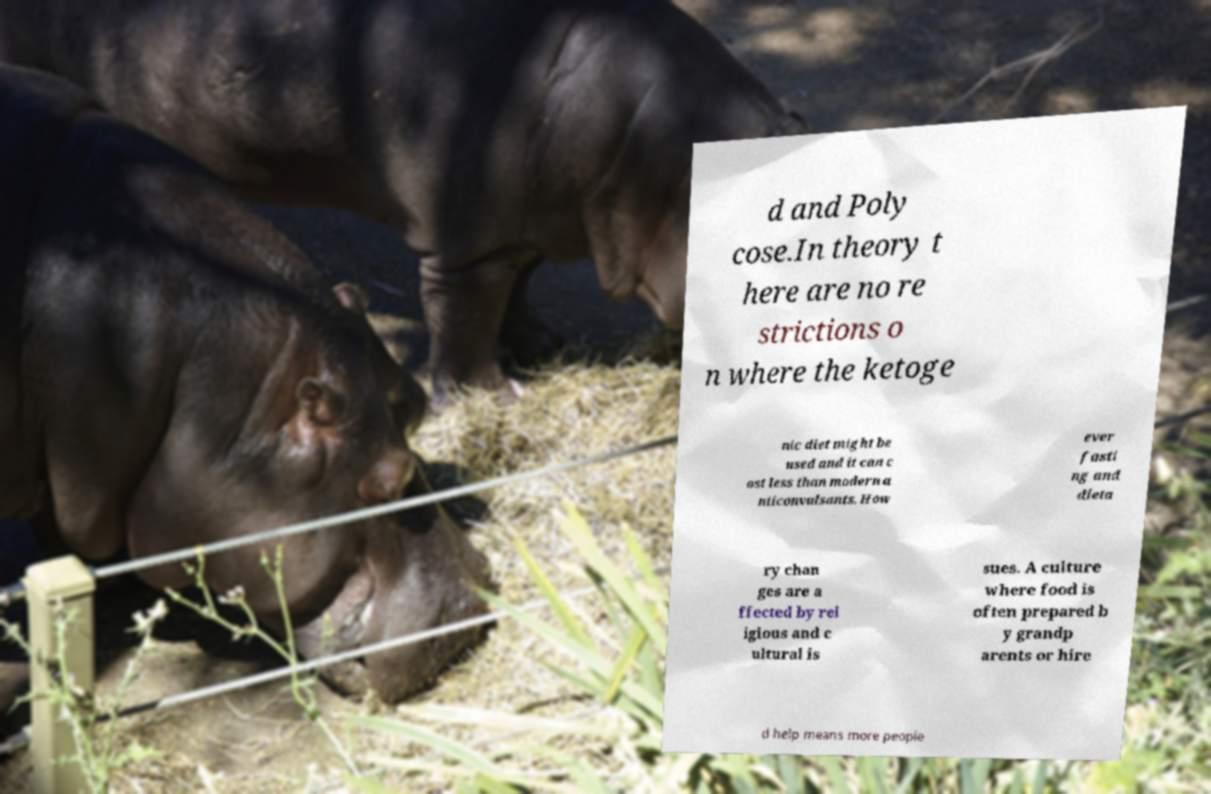There's text embedded in this image that I need extracted. Can you transcribe it verbatim? d and Poly cose.In theory t here are no re strictions o n where the ketoge nic diet might be used and it can c ost less than modern a nticonvulsants. How ever fasti ng and dieta ry chan ges are a ffected by rel igious and c ultural is sues. A culture where food is often prepared b y grandp arents or hire d help means more people 